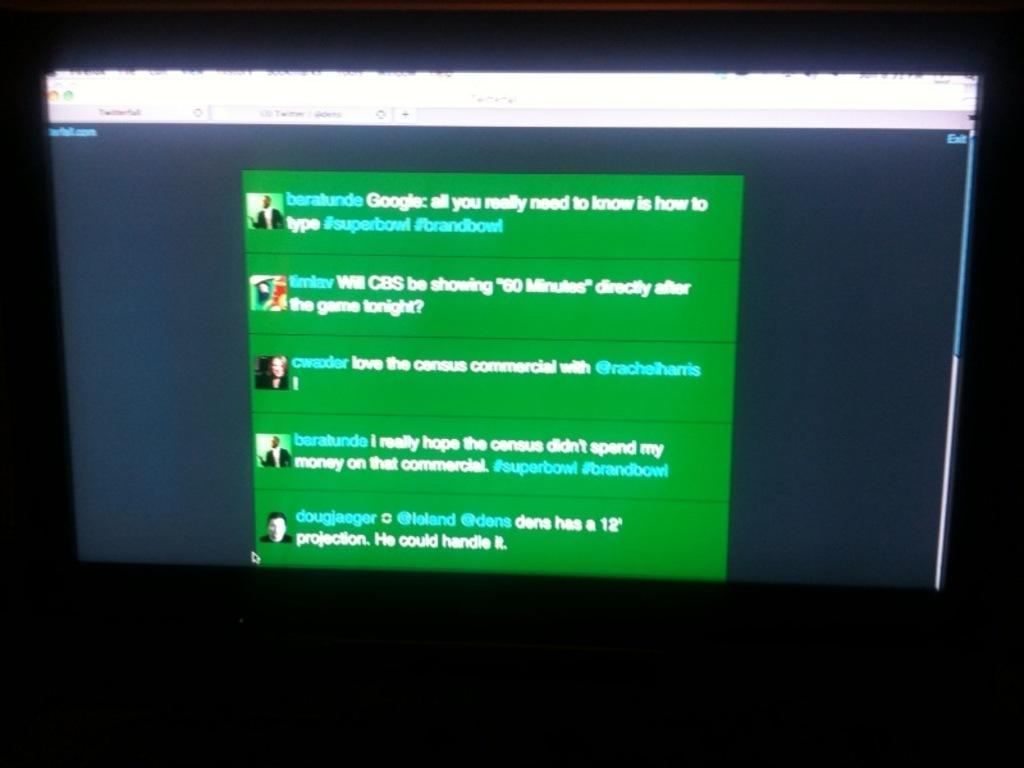<image>
Summarize the visual content of the image. A group of different texts on a screen including a mention of CBS. 